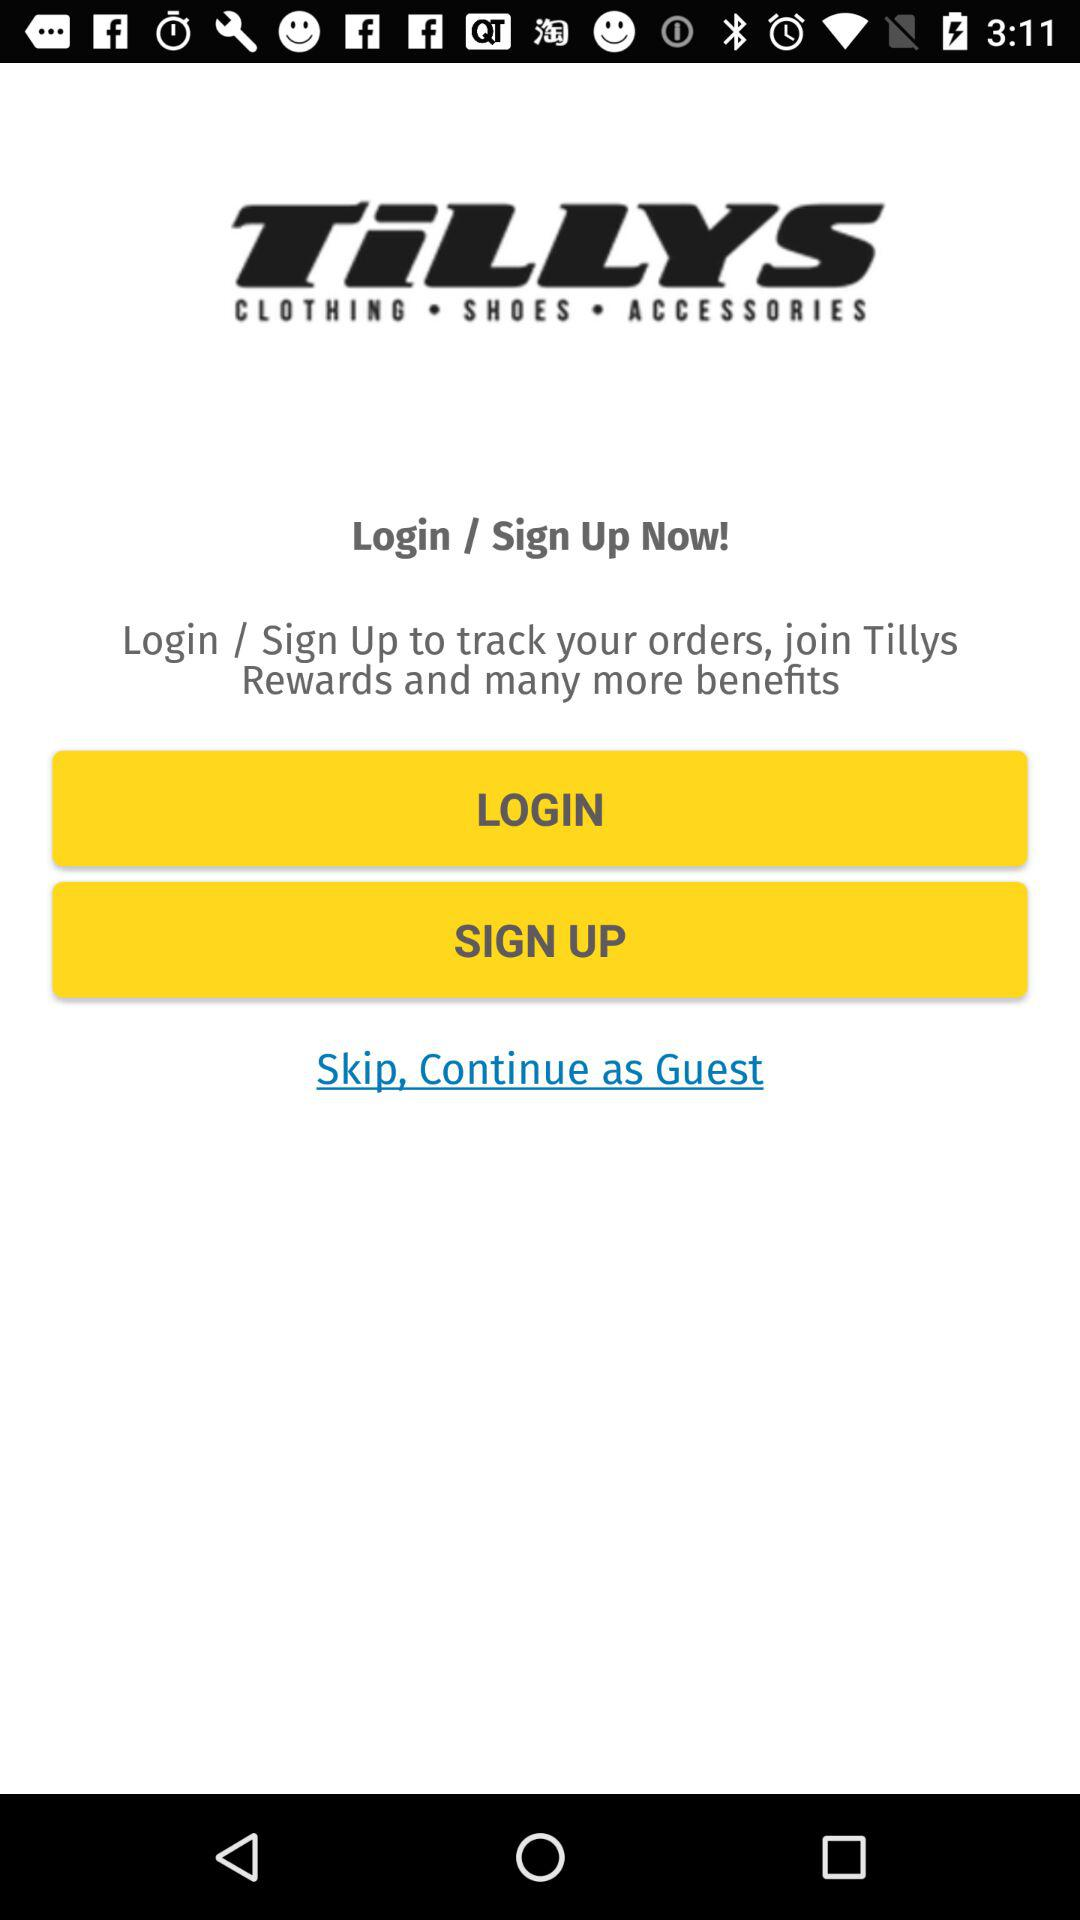What kind of products might I find in the Tillys application? The Tillys application offers a variety of youth-oriented clothing, shoes, and accessories. They carry popular brands and the latest trends, with options catered to diverse styles such as casual, athletic, and streetwear. Additionally, they may offer seasonal items and exclusive deals through the app. 